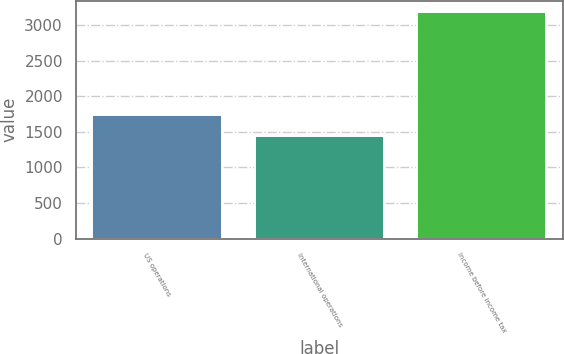Convert chart to OTSL. <chart><loc_0><loc_0><loc_500><loc_500><bar_chart><fcel>US operations<fcel>International operations<fcel>Income before income tax<nl><fcel>1733<fcel>1449<fcel>3182<nl></chart> 